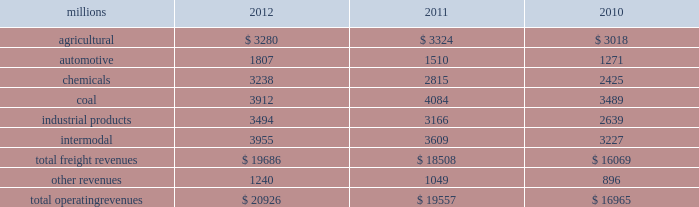Notes to the consolidated financial statements union pacific corporation and subsidiary companies for purposes of this report , unless the context otherwise requires , all references herein to the 201ccorporation 201d , 201cupc 201d , 201cwe 201d , 201cus 201d , and 201cour 201d mean union pacific corporation and its subsidiaries , including union pacific railroad company , which will be separately referred to herein as 201cuprr 201d or the 201crailroad 201d .
Nature of operations operations and segmentation 2013 we are a class i railroad operating in the u.s .
Our network includes 31868 route miles , linking pacific coast and gulf coast ports with the midwest and eastern u.s .
Gateways and providing several corridors to key mexican gateways .
We own 26020 miles and operate on the remainder pursuant to trackage rights or leases .
We serve the western two-thirds of the country and maintain coordinated schedules with other rail carriers for the handling of freight to and from the atlantic coast , the pacific coast , the southeast , the southwest , canada , and mexico .
Export and import traffic is moved through gulf coast and pacific coast ports and across the mexican and canadian borders .
The railroad , along with its subsidiaries and rail affiliates , is our one reportable operating segment .
Although we provide and review revenue by commodity group , we analyze the net financial results of the railroad as one segment due to the integrated nature of our rail network .
The table provides freight revenue by commodity group : millions 2012 2011 2010 .
Although our revenues are principally derived from customers domiciled in the u.s. , the ultimate points of origination or destination for some products transported by us are outside the u.s .
Each of our commodity groups includes revenue from shipments to and from mexico .
Included in the above table are revenues from our mexico business which amounted to $ 1.9 billion in 2012 , $ 1.8 billion in 2011 , and $ 1.6 billion in 2010 .
Basis of presentation 2013 the consolidated financial statements are presented in accordance with accounting principles generally accepted in the u.s .
( gaap ) as codified in the financial accounting standards board ( fasb ) accounting standards codification ( asc ) .
Significant accounting policies principles of consolidation 2013 the consolidated financial statements include the accounts of union pacific corporation and all of its subsidiaries .
Investments in affiliated companies ( 20% ( 20 % ) to 50% ( 50 % ) owned ) are accounted for using the equity method of accounting .
All intercompany transactions are eliminated .
We currently have no less than majority-owned investments that require consolidation under variable interest entity requirements .
Cash and cash equivalents 2013 cash equivalents consist of investments with original maturities of three months or less .
Accounts receivable 2013 accounts receivable includes receivables reduced by an allowance for doubtful accounts .
The allowance is based upon historical losses , credit worthiness of customers , and current economic conditions .
Receivables not expected to be collected in one year and the associated allowances are classified as other assets in our consolidated statements of financial position. .
What percentage of total freight revenues was the industrial products commodity group in 2011? 
Computations: (3166 / 18508)
Answer: 0.17106. 